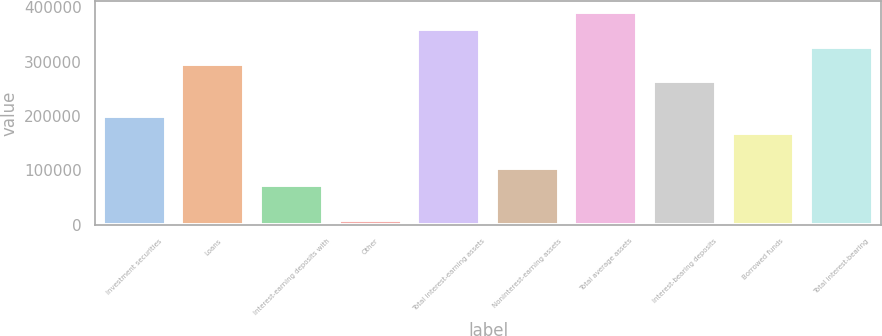Convert chart. <chart><loc_0><loc_0><loc_500><loc_500><bar_chart><fcel>Investment securities<fcel>Loans<fcel>Interest-earning deposits with<fcel>Other<fcel>Total interest-earning assets<fcel>Noninterest-earning assets<fcel>Total average assets<fcel>Interest-bearing deposits<fcel>Borrowed funds<fcel>Total interest-bearing<nl><fcel>200165<fcel>295931<fcel>72477<fcel>8633<fcel>359775<fcel>104399<fcel>391697<fcel>264009<fcel>168243<fcel>327853<nl></chart> 